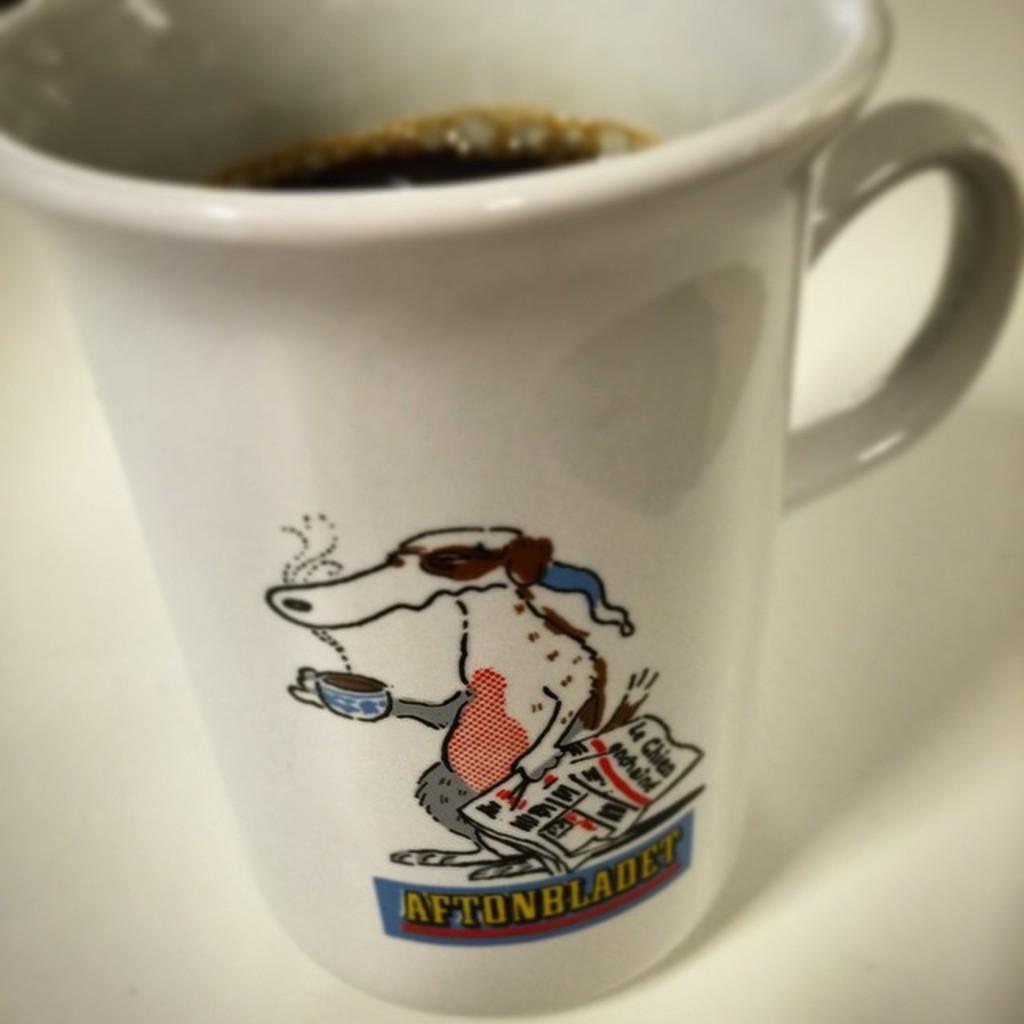Could you give a brief overview of what you see in this image? In this image I can see a cup which is white in color with black colored liquid in it on the white colored surface and I can see something printed on the cup. 